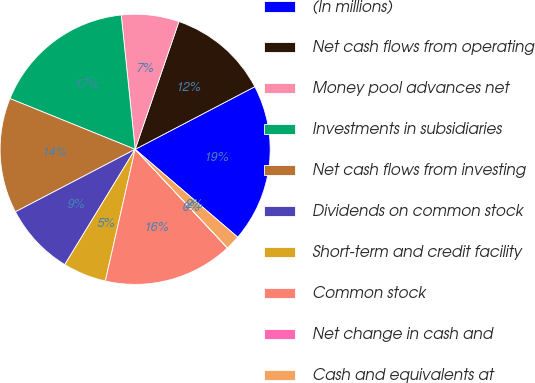Convert chart to OTSL. <chart><loc_0><loc_0><loc_500><loc_500><pie_chart><fcel>(In millions)<fcel>Net cash flows from operating<fcel>Money pool advances net<fcel>Investments in subsidiaries<fcel>Net cash flows from investing<fcel>Dividends on common stock<fcel>Short-term and credit facility<fcel>Common stock<fcel>Net change in cash and<fcel>Cash and equivalents at<nl><fcel>18.95%<fcel>12.07%<fcel>6.9%<fcel>17.23%<fcel>13.79%<fcel>8.62%<fcel>5.18%<fcel>15.51%<fcel>0.02%<fcel>1.74%<nl></chart> 